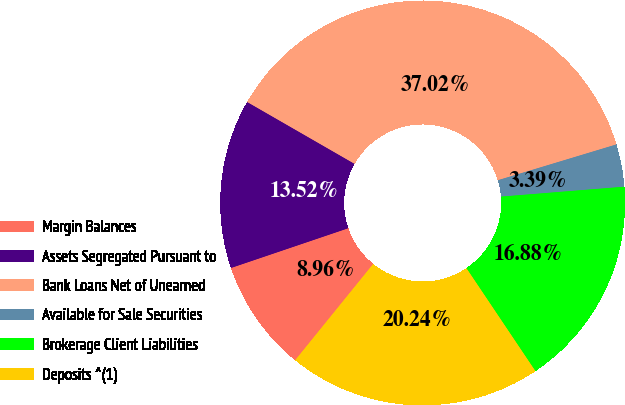Convert chart to OTSL. <chart><loc_0><loc_0><loc_500><loc_500><pie_chart><fcel>Margin Balances<fcel>Assets Segregated Pursuant to<fcel>Bank Loans Net of Unearned<fcel>Available for Sale Securities<fcel>Brokerage Client Liabilities<fcel>Deposits ^(1)<nl><fcel>8.96%<fcel>13.52%<fcel>37.02%<fcel>3.39%<fcel>16.88%<fcel>20.24%<nl></chart> 